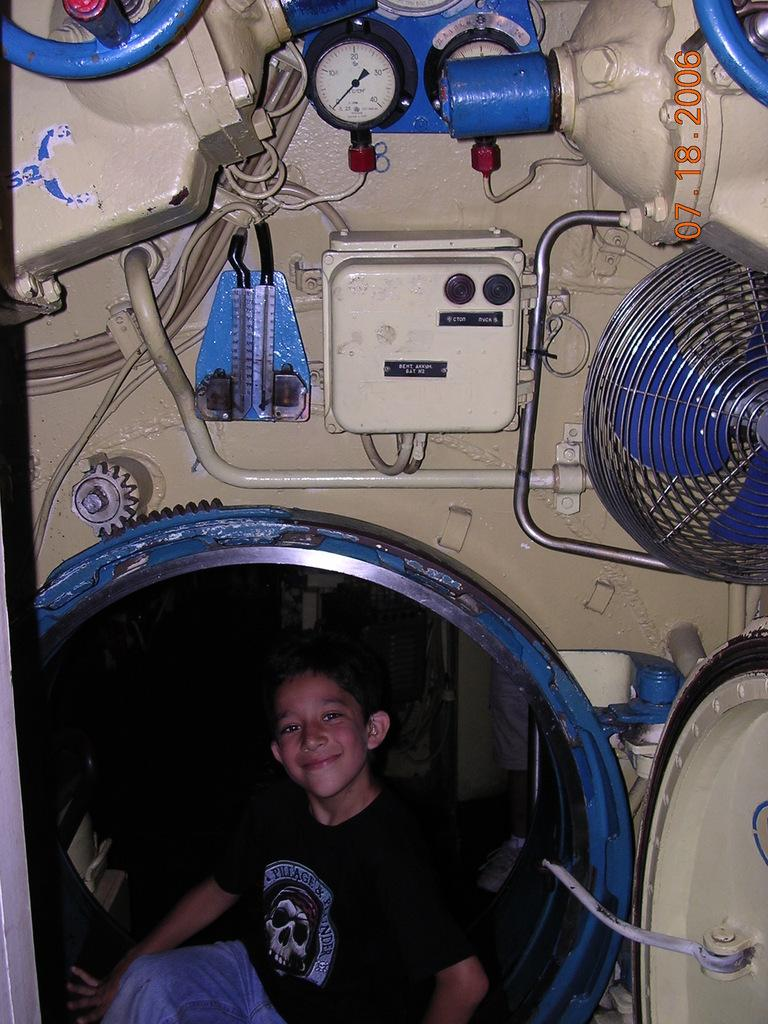Who is the main subject in the image? There is a boy in the image. What is the boy doing in the image? The boy is sitting in a vehicle. What level of management does the boy hold in the company? There is no information about the boy's management level or any company in the image. 